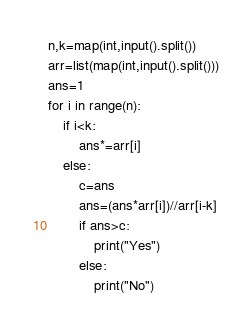<code> <loc_0><loc_0><loc_500><loc_500><_Python_>n,k=map(int,input().split())
arr=list(map(int,input().split()))
ans=1
for i in range(n):
    if i<k:
        ans*=arr[i]
    else:
        c=ans
        ans=(ans*arr[i])//arr[i-k]
        if ans>c:
            print("Yes")
        else:
            print("No")


</code> 